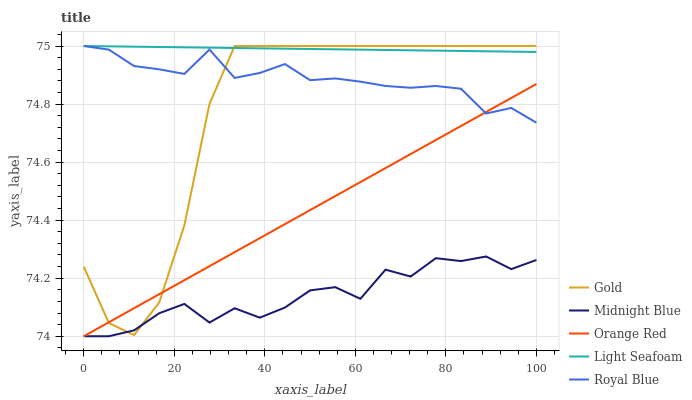Does Light Seafoam have the minimum area under the curve?
Answer yes or no. No. Does Midnight Blue have the maximum area under the curve?
Answer yes or no. No. Is Midnight Blue the smoothest?
Answer yes or no. No. Is Light Seafoam the roughest?
Answer yes or no. No. Does Light Seafoam have the lowest value?
Answer yes or no. No. Does Midnight Blue have the highest value?
Answer yes or no. No. Is Orange Red less than Light Seafoam?
Answer yes or no. Yes. Is Royal Blue greater than Midnight Blue?
Answer yes or no. Yes. Does Orange Red intersect Light Seafoam?
Answer yes or no. No. 